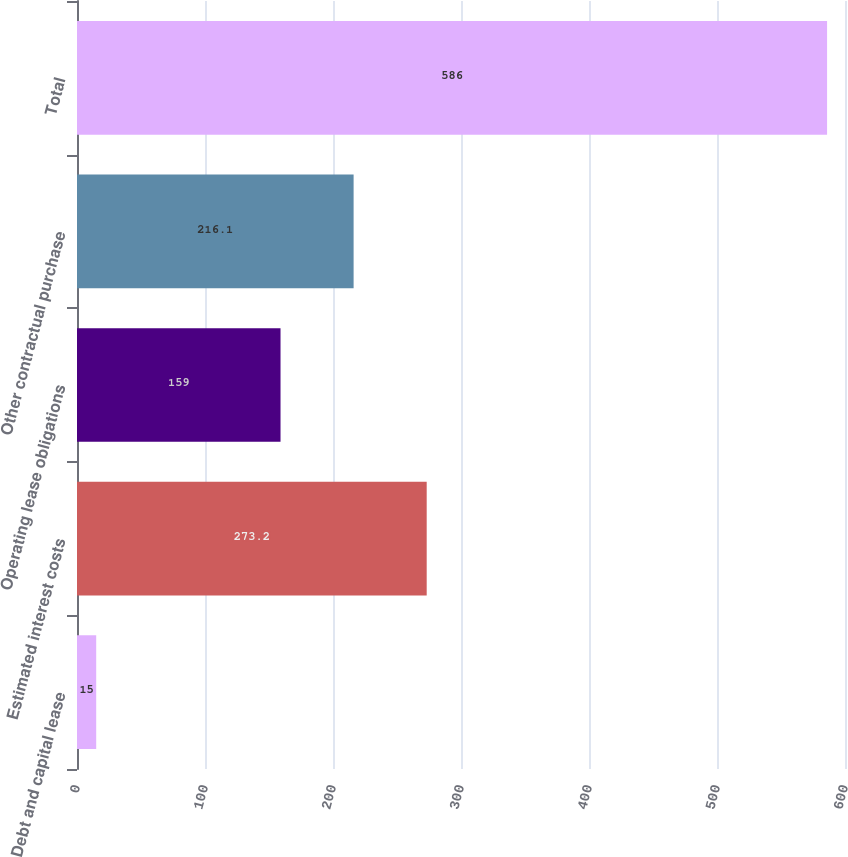Convert chart. <chart><loc_0><loc_0><loc_500><loc_500><bar_chart><fcel>Debt and capital lease<fcel>Estimated interest costs<fcel>Operating lease obligations<fcel>Other contractual purchase<fcel>Total<nl><fcel>15<fcel>273.2<fcel>159<fcel>216.1<fcel>586<nl></chart> 